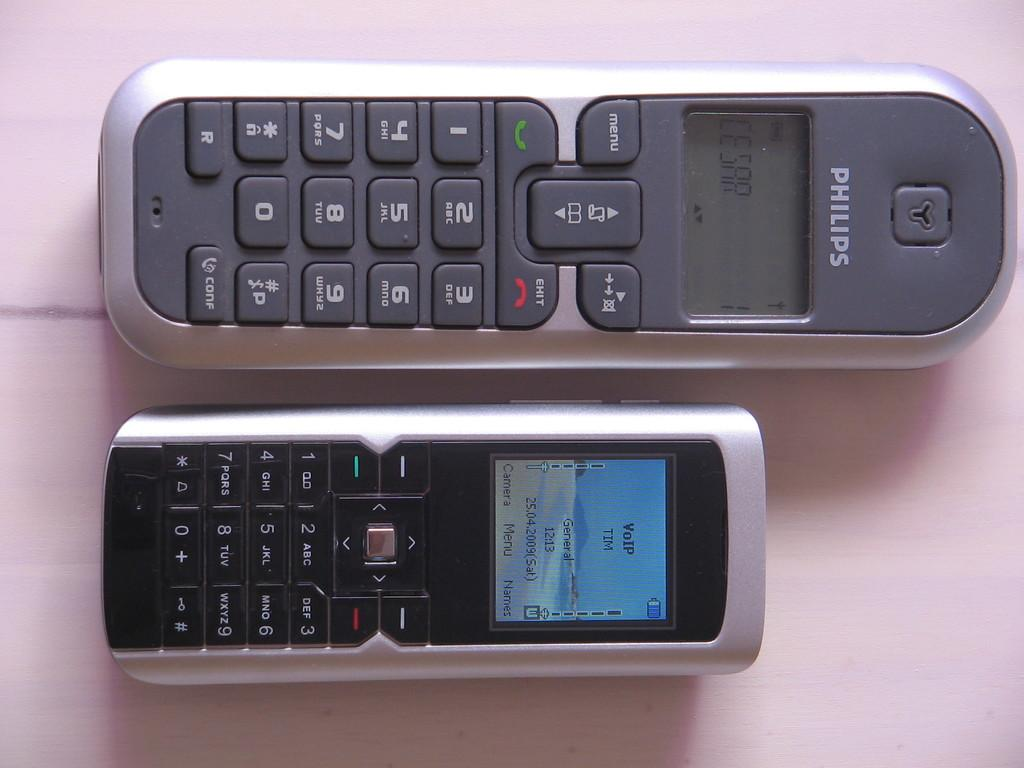<image>
Describe the image concisely. Two phones lying ona pink surface - the top one which is made by Philips says CESAR; the bottom one says: VOIP TIM. 